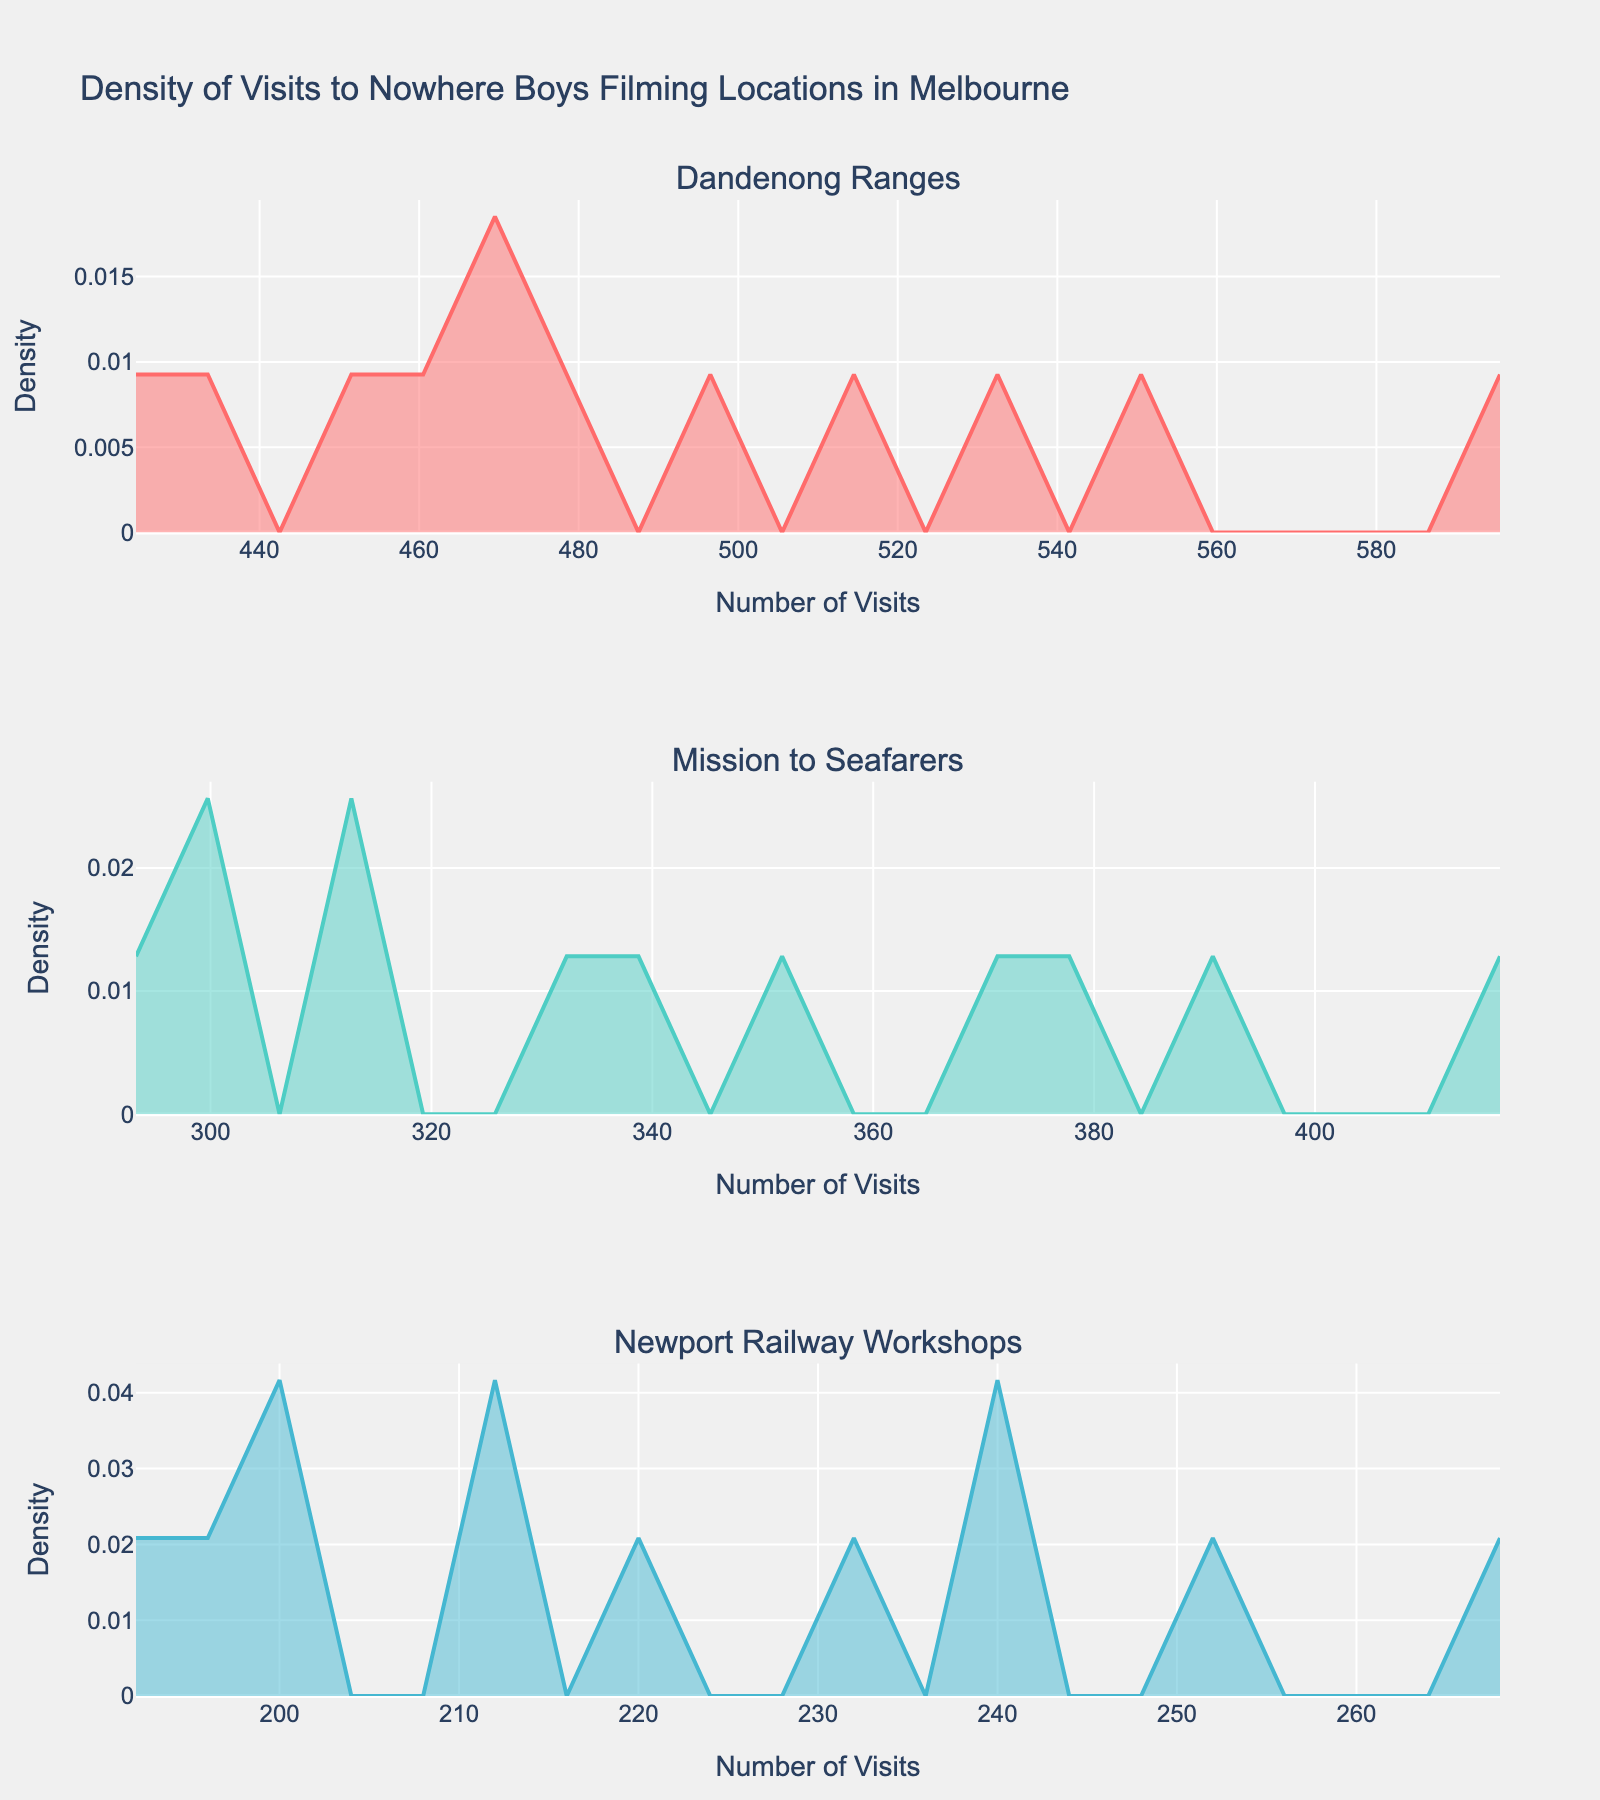What's the title of the figure? The title is located at the top center of the figure.
Answer: Density of Visits to Nowhere Boys Filming Locations in Melbourne How many different filming locations are shown in the figure? The figure displays three separate density plots, each marked by subplot titles.
Answer: 3 Which filming location shows the highest density of visits in November? By examining the peak density values in November from the subplots, Dandenong Ranges has the highest density.
Answer: Dandenong Ranges Between Dandenong Ranges and Mission to Seafarers, which location has more variation in visit frequency? By comparing the spread and peaks of the density plots, Dandenong Ranges shows more spread, indicating higher variation.
Answer: Dandenong Ranges What is the month with the lowest number of visits to the Newport Railway Workshops? Looking at the density plot, the lowest density peak value corresponds to July.
Answer: July Which location has the most consistent number of visits throughout the year? Mission to Seafarers shows relatively consistent density values, with fewer fluctuations.
Answer: Mission to Seafarers What is the trend in the number of visits to Dandenong Ranges from January to December? The density plot for Dandenong Ranges shows an increasing trend in visitation over the year.
Answer: Increasing Compare the density peaks of visits in December for all locations. Which one is highest? The peaks in the density plots show Dandenong Ranges has the highest peak in December.
Answer: Dandenong Ranges What's the average number of visits to Newport Railway Workshops across the year based on the density plot? Summing up the visits from January to December and dividing by 12, the average can be calculated: (200 + 210 + 230 + 220 + 240 + 200 + 190 + 195 + 210 + 240 + 250 + 270) ÷ 12 = 220 visits.
Answer: 220 